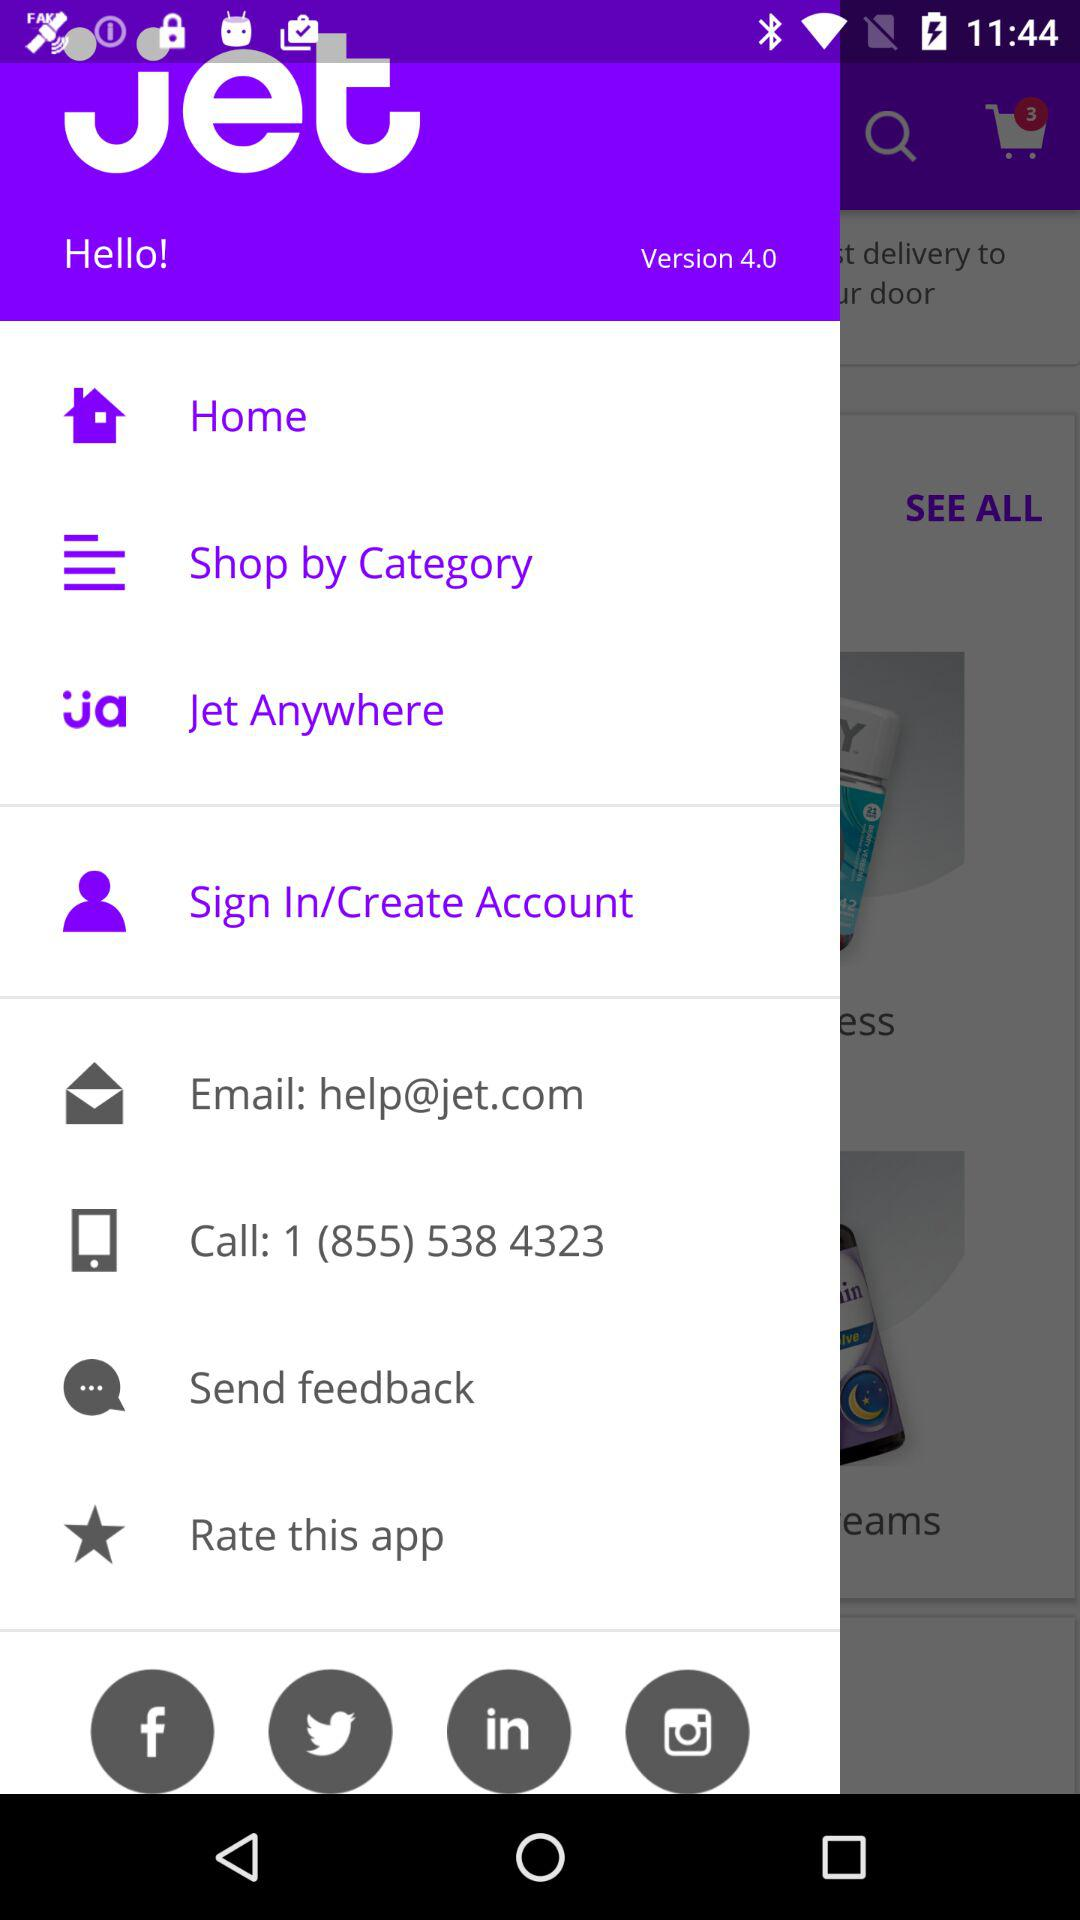What is the email address? The email address is help@jet.com. 